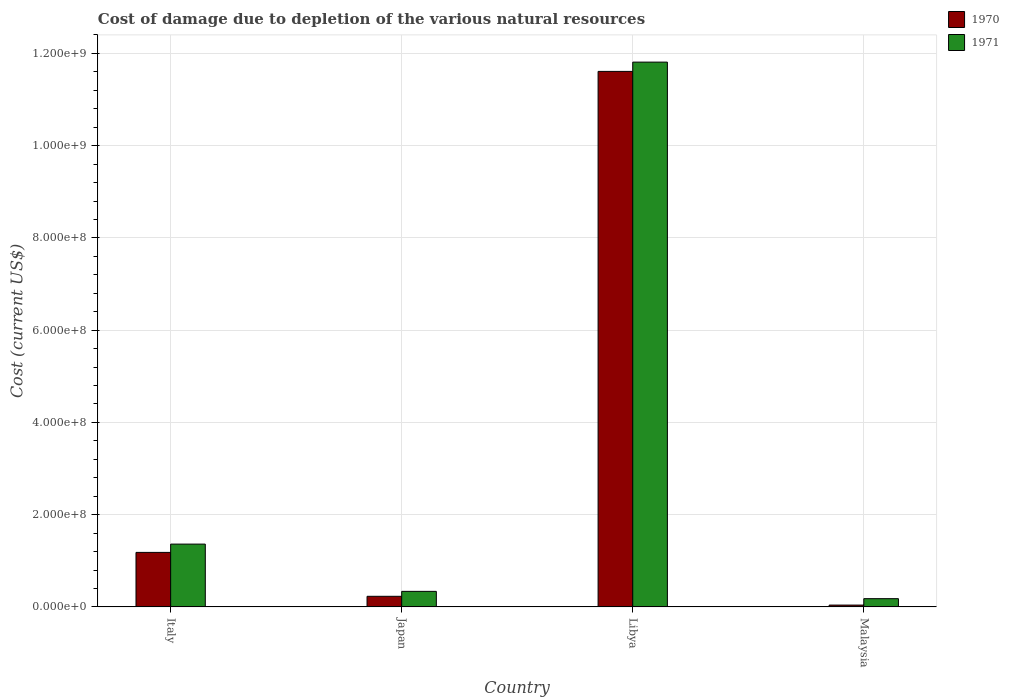How many different coloured bars are there?
Provide a succinct answer. 2. Are the number of bars on each tick of the X-axis equal?
Keep it short and to the point. Yes. How many bars are there on the 1st tick from the left?
Your response must be concise. 2. What is the label of the 4th group of bars from the left?
Provide a succinct answer. Malaysia. What is the cost of damage caused due to the depletion of various natural resources in 1970 in Malaysia?
Offer a very short reply. 3.97e+06. Across all countries, what is the maximum cost of damage caused due to the depletion of various natural resources in 1970?
Offer a terse response. 1.16e+09. Across all countries, what is the minimum cost of damage caused due to the depletion of various natural resources in 1971?
Make the answer very short. 1.79e+07. In which country was the cost of damage caused due to the depletion of various natural resources in 1970 maximum?
Keep it short and to the point. Libya. In which country was the cost of damage caused due to the depletion of various natural resources in 1970 minimum?
Keep it short and to the point. Malaysia. What is the total cost of damage caused due to the depletion of various natural resources in 1971 in the graph?
Offer a terse response. 1.37e+09. What is the difference between the cost of damage caused due to the depletion of various natural resources in 1970 in Italy and that in Japan?
Give a very brief answer. 9.52e+07. What is the difference between the cost of damage caused due to the depletion of various natural resources in 1971 in Libya and the cost of damage caused due to the depletion of various natural resources in 1970 in Malaysia?
Your answer should be compact. 1.18e+09. What is the average cost of damage caused due to the depletion of various natural resources in 1971 per country?
Your answer should be compact. 3.42e+08. What is the difference between the cost of damage caused due to the depletion of various natural resources of/in 1970 and cost of damage caused due to the depletion of various natural resources of/in 1971 in Malaysia?
Your response must be concise. -1.39e+07. In how many countries, is the cost of damage caused due to the depletion of various natural resources in 1970 greater than 80000000 US$?
Offer a very short reply. 2. What is the ratio of the cost of damage caused due to the depletion of various natural resources in 1970 in Japan to that in Malaysia?
Keep it short and to the point. 5.79. Is the difference between the cost of damage caused due to the depletion of various natural resources in 1970 in Italy and Malaysia greater than the difference between the cost of damage caused due to the depletion of various natural resources in 1971 in Italy and Malaysia?
Offer a very short reply. No. What is the difference between the highest and the second highest cost of damage caused due to the depletion of various natural resources in 1971?
Your answer should be very brief. 1.02e+08. What is the difference between the highest and the lowest cost of damage caused due to the depletion of various natural resources in 1970?
Keep it short and to the point. 1.16e+09. In how many countries, is the cost of damage caused due to the depletion of various natural resources in 1970 greater than the average cost of damage caused due to the depletion of various natural resources in 1970 taken over all countries?
Your response must be concise. 1. Is the sum of the cost of damage caused due to the depletion of various natural resources in 1970 in Italy and Malaysia greater than the maximum cost of damage caused due to the depletion of various natural resources in 1971 across all countries?
Your answer should be very brief. No. What does the 2nd bar from the left in Italy represents?
Your answer should be compact. 1971. What does the 1st bar from the right in Malaysia represents?
Offer a terse response. 1971. How many bars are there?
Keep it short and to the point. 8. Are all the bars in the graph horizontal?
Ensure brevity in your answer.  No. How many countries are there in the graph?
Keep it short and to the point. 4. What is the difference between two consecutive major ticks on the Y-axis?
Provide a short and direct response. 2.00e+08. Does the graph contain grids?
Provide a short and direct response. Yes. How are the legend labels stacked?
Make the answer very short. Vertical. What is the title of the graph?
Your answer should be very brief. Cost of damage due to depletion of the various natural resources. What is the label or title of the Y-axis?
Your response must be concise. Cost (current US$). What is the Cost (current US$) of 1970 in Italy?
Ensure brevity in your answer.  1.18e+08. What is the Cost (current US$) of 1971 in Italy?
Your response must be concise. 1.36e+08. What is the Cost (current US$) in 1970 in Japan?
Your answer should be compact. 2.30e+07. What is the Cost (current US$) of 1971 in Japan?
Provide a succinct answer. 3.37e+07. What is the Cost (current US$) of 1970 in Libya?
Your response must be concise. 1.16e+09. What is the Cost (current US$) in 1971 in Libya?
Offer a very short reply. 1.18e+09. What is the Cost (current US$) of 1970 in Malaysia?
Ensure brevity in your answer.  3.97e+06. What is the Cost (current US$) in 1971 in Malaysia?
Give a very brief answer. 1.79e+07. Across all countries, what is the maximum Cost (current US$) of 1970?
Ensure brevity in your answer.  1.16e+09. Across all countries, what is the maximum Cost (current US$) of 1971?
Provide a short and direct response. 1.18e+09. Across all countries, what is the minimum Cost (current US$) in 1970?
Ensure brevity in your answer.  3.97e+06. Across all countries, what is the minimum Cost (current US$) in 1971?
Offer a very short reply. 1.79e+07. What is the total Cost (current US$) in 1970 in the graph?
Make the answer very short. 1.31e+09. What is the total Cost (current US$) in 1971 in the graph?
Offer a terse response. 1.37e+09. What is the difference between the Cost (current US$) in 1970 in Italy and that in Japan?
Ensure brevity in your answer.  9.52e+07. What is the difference between the Cost (current US$) in 1971 in Italy and that in Japan?
Provide a short and direct response. 1.02e+08. What is the difference between the Cost (current US$) in 1970 in Italy and that in Libya?
Ensure brevity in your answer.  -1.04e+09. What is the difference between the Cost (current US$) in 1971 in Italy and that in Libya?
Make the answer very short. -1.05e+09. What is the difference between the Cost (current US$) of 1970 in Italy and that in Malaysia?
Your answer should be compact. 1.14e+08. What is the difference between the Cost (current US$) in 1971 in Italy and that in Malaysia?
Your answer should be very brief. 1.18e+08. What is the difference between the Cost (current US$) of 1970 in Japan and that in Libya?
Offer a terse response. -1.14e+09. What is the difference between the Cost (current US$) in 1971 in Japan and that in Libya?
Keep it short and to the point. -1.15e+09. What is the difference between the Cost (current US$) in 1970 in Japan and that in Malaysia?
Provide a succinct answer. 1.90e+07. What is the difference between the Cost (current US$) of 1971 in Japan and that in Malaysia?
Provide a short and direct response. 1.58e+07. What is the difference between the Cost (current US$) of 1970 in Libya and that in Malaysia?
Ensure brevity in your answer.  1.16e+09. What is the difference between the Cost (current US$) of 1971 in Libya and that in Malaysia?
Your response must be concise. 1.16e+09. What is the difference between the Cost (current US$) of 1970 in Italy and the Cost (current US$) of 1971 in Japan?
Ensure brevity in your answer.  8.45e+07. What is the difference between the Cost (current US$) in 1970 in Italy and the Cost (current US$) in 1971 in Libya?
Offer a terse response. -1.06e+09. What is the difference between the Cost (current US$) in 1970 in Italy and the Cost (current US$) in 1971 in Malaysia?
Give a very brief answer. 1.00e+08. What is the difference between the Cost (current US$) in 1970 in Japan and the Cost (current US$) in 1971 in Libya?
Ensure brevity in your answer.  -1.16e+09. What is the difference between the Cost (current US$) in 1970 in Japan and the Cost (current US$) in 1971 in Malaysia?
Offer a very short reply. 5.12e+06. What is the difference between the Cost (current US$) of 1970 in Libya and the Cost (current US$) of 1971 in Malaysia?
Offer a very short reply. 1.14e+09. What is the average Cost (current US$) of 1970 per country?
Provide a succinct answer. 3.27e+08. What is the average Cost (current US$) of 1971 per country?
Provide a succinct answer. 3.42e+08. What is the difference between the Cost (current US$) in 1970 and Cost (current US$) in 1971 in Italy?
Offer a terse response. -1.80e+07. What is the difference between the Cost (current US$) in 1970 and Cost (current US$) in 1971 in Japan?
Offer a terse response. -1.07e+07. What is the difference between the Cost (current US$) in 1970 and Cost (current US$) in 1971 in Libya?
Your answer should be compact. -2.01e+07. What is the difference between the Cost (current US$) in 1970 and Cost (current US$) in 1971 in Malaysia?
Your response must be concise. -1.39e+07. What is the ratio of the Cost (current US$) in 1970 in Italy to that in Japan?
Make the answer very short. 5.14. What is the ratio of the Cost (current US$) of 1971 in Italy to that in Japan?
Give a very brief answer. 4.04. What is the ratio of the Cost (current US$) in 1970 in Italy to that in Libya?
Your answer should be compact. 0.1. What is the ratio of the Cost (current US$) in 1971 in Italy to that in Libya?
Provide a succinct answer. 0.12. What is the ratio of the Cost (current US$) in 1970 in Italy to that in Malaysia?
Offer a terse response. 29.77. What is the ratio of the Cost (current US$) in 1971 in Italy to that in Malaysia?
Give a very brief answer. 7.62. What is the ratio of the Cost (current US$) in 1970 in Japan to that in Libya?
Ensure brevity in your answer.  0.02. What is the ratio of the Cost (current US$) of 1971 in Japan to that in Libya?
Your response must be concise. 0.03. What is the ratio of the Cost (current US$) in 1970 in Japan to that in Malaysia?
Give a very brief answer. 5.79. What is the ratio of the Cost (current US$) of 1971 in Japan to that in Malaysia?
Give a very brief answer. 1.88. What is the ratio of the Cost (current US$) in 1970 in Libya to that in Malaysia?
Keep it short and to the point. 292.43. What is the ratio of the Cost (current US$) of 1971 in Libya to that in Malaysia?
Your answer should be compact. 66.06. What is the difference between the highest and the second highest Cost (current US$) in 1970?
Offer a very short reply. 1.04e+09. What is the difference between the highest and the second highest Cost (current US$) of 1971?
Your response must be concise. 1.05e+09. What is the difference between the highest and the lowest Cost (current US$) of 1970?
Provide a succinct answer. 1.16e+09. What is the difference between the highest and the lowest Cost (current US$) of 1971?
Offer a terse response. 1.16e+09. 